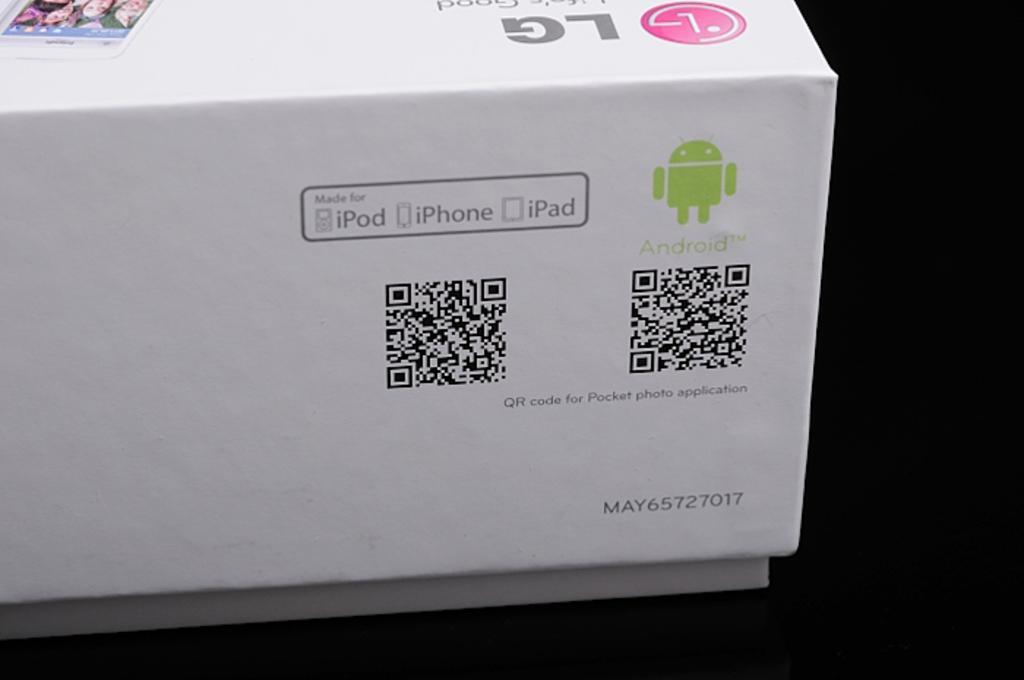<image>
Offer a succinct explanation of the picture presented. An LG device is listed as being made for iPhone and Android. 